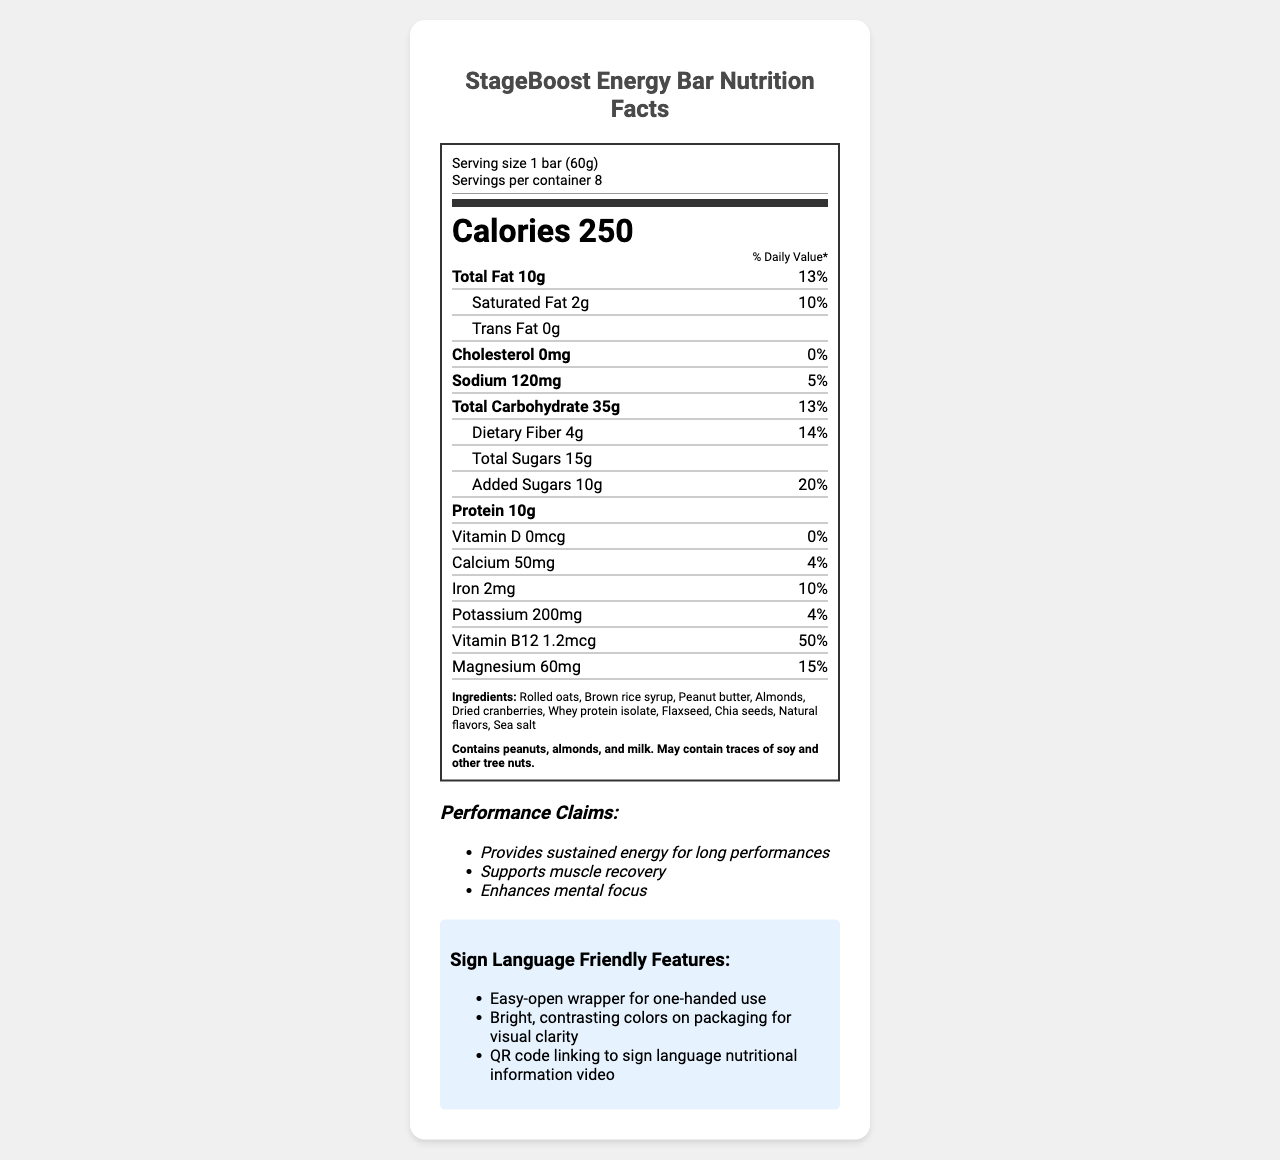what is the serving size of the StageBoost Energy Bar? The document specifies that the serving size is "1 bar (60g)".
Answer: 1 bar (60g) how many calories are in one serving of the StageBoost Energy Bar? The document states that there are 250 calories in one serving.
Answer: 250 what is the total fat content in one serving? The document lists the total fat amount as 10g per serving.
Answer: 10g what percentage of the daily value of magnesium does one bar provide? The document shows that one bar provides 15% of the daily value for magnesium.
Answer: 15% how much protein is in one serving of the StageBoost Energy Bar? The protein content is listed as 10g per serving.
Answer: 10g what is the amount of dietary fiber in one serving? The document specifies 4g of dietary fiber per serving.
Answer: 4g which ingredient is not listed in the document? A. Rolled oats B. Brown rice syrup C. Walnuts The document lists ingredients including rolled oats, brown rice syrup, but not walnuts.
Answer: C which of the following sign language-friendly features is included for the StageBoost Energy Bar? A. Braille on packaging B. Easy-open wrapper C. Extra-large text The document mentions that the packaging includes an easy-open wrapper for one-handed use as a sign language-friendly feature.
Answer: B does the StageBoost Energy Bar contain any trans fat? The document clearly states that there is 0g of trans fat in one serving.
Answer: No summarize the main information presented in the document. The document includes various sections stating the nutrition facts, ingredients, allergen information, performance benefits, and accessibility features for the StageBoost Energy Bar.
Answer: The document provides detailed nutrition facts for the StageBoost Energy Bar, a high-energy snack bar designed for performers. Each bar has 250 calories, 10g of total fat, 10g of protein, and various vitamins and minerals. It also lists the ingredients, allergen information, performance claims, and sign language-friendly features. can the StageBoost Energy Bar's performance claims be independently verified based on the document? The performance claims listed in the document ("Provides sustained energy for long performances", "Supports muscle recovery", "Enhances mental focus") cannot be independently verified based solely on the nutrition facts and other information provided in the document.
Answer: Not enough information 